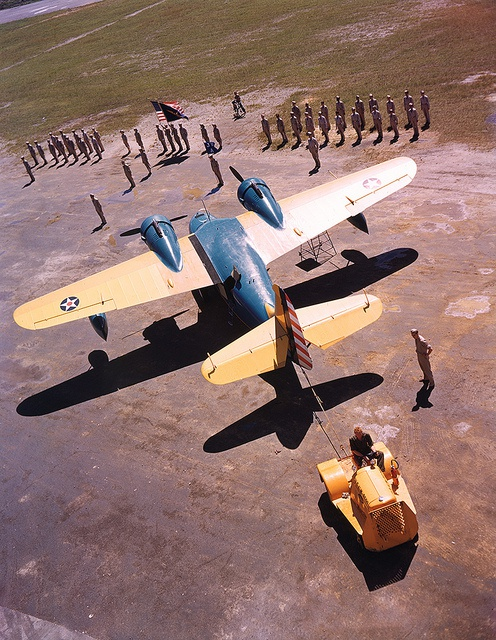Describe the objects in this image and their specific colors. I can see airplane in purple, white, tan, black, and darkgray tones, people in purple, gray, black, darkgray, and lightpink tones, people in purple, black, maroon, and brown tones, people in purple, maroon, black, brown, and lightpink tones, and people in purple, maroon, black, lightpink, and brown tones in this image. 